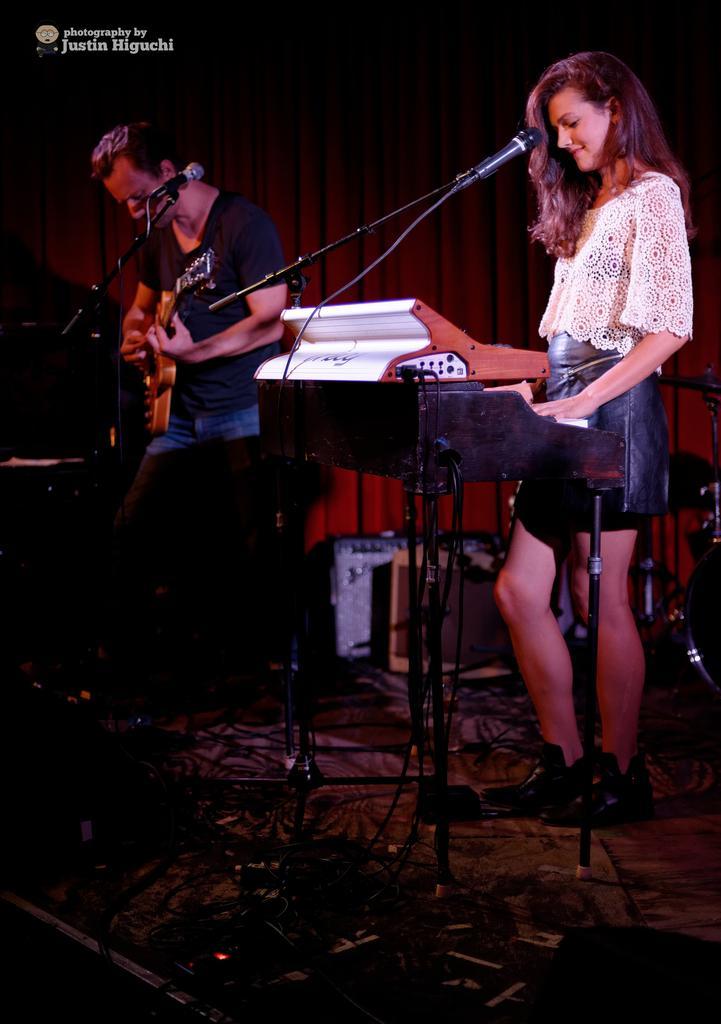Could you give a brief overview of what you see in this image? This picture shows a woman standing and playing a piano with the help of a microphone and a man standing and playing a guitar and we see a microphone in front of him. 